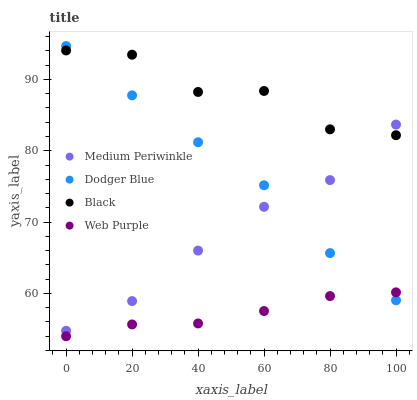Does Web Purple have the minimum area under the curve?
Answer yes or no. Yes. Does Black have the maximum area under the curve?
Answer yes or no. Yes. Does Medium Periwinkle have the minimum area under the curve?
Answer yes or no. No. Does Medium Periwinkle have the maximum area under the curve?
Answer yes or no. No. Is Web Purple the smoothest?
Answer yes or no. Yes. Is Black the roughest?
Answer yes or no. Yes. Is Medium Periwinkle the smoothest?
Answer yes or no. No. Is Medium Periwinkle the roughest?
Answer yes or no. No. Does Web Purple have the lowest value?
Answer yes or no. Yes. Does Medium Periwinkle have the lowest value?
Answer yes or no. No. Does Dodger Blue have the highest value?
Answer yes or no. Yes. Does Medium Periwinkle have the highest value?
Answer yes or no. No. Is Web Purple less than Black?
Answer yes or no. Yes. Is Black greater than Web Purple?
Answer yes or no. Yes. Does Black intersect Medium Periwinkle?
Answer yes or no. Yes. Is Black less than Medium Periwinkle?
Answer yes or no. No. Is Black greater than Medium Periwinkle?
Answer yes or no. No. Does Web Purple intersect Black?
Answer yes or no. No. 